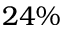<formula> <loc_0><loc_0><loc_500><loc_500>2 4 \%</formula> 